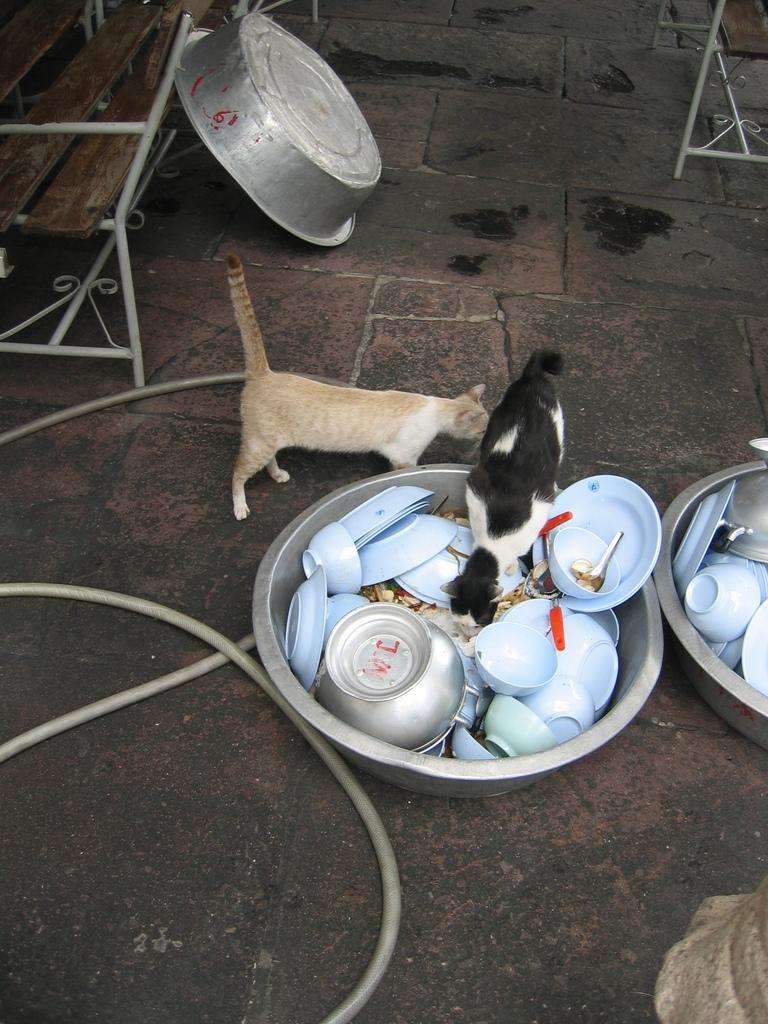How many cats are in the image? There are two cats in the image. What is the vessel with empty bowls used for? The vessel with empty bowls is likely used for serving food. What type of food is in the vessel? There is food in the vessel. What can be seen in the background of the image? There are vessels visible in the background of the image. What color is the powder used to plot the cats' movements in the image? There is no powder or plotting of the cats' movements in the image. 